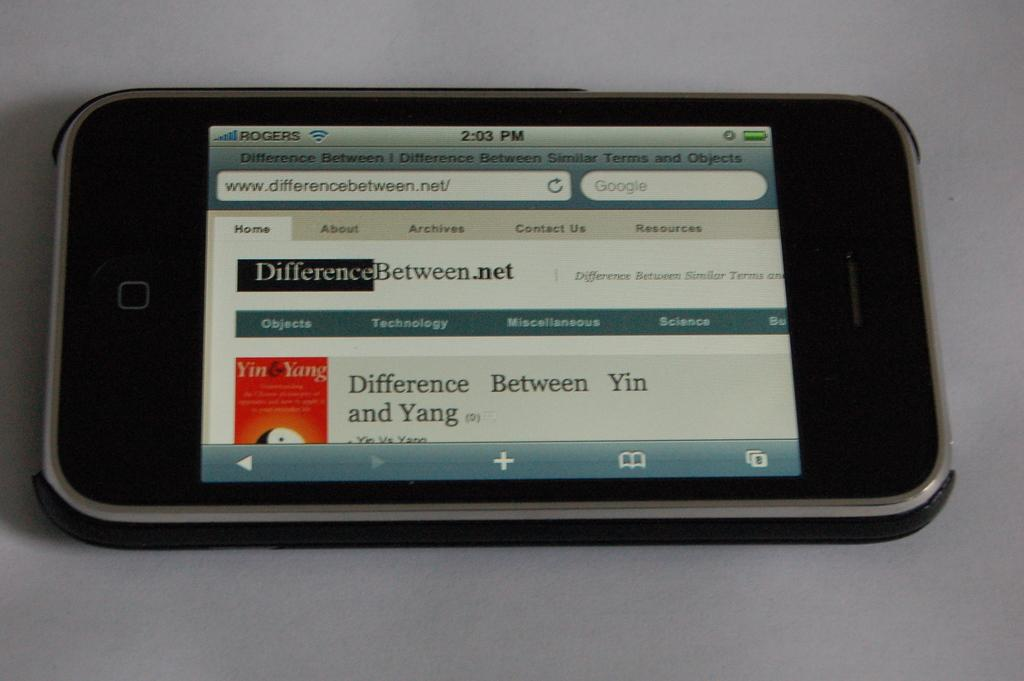<image>
Share a concise interpretation of the image provided. A phone with the differencebetween.net page showing on the screen 